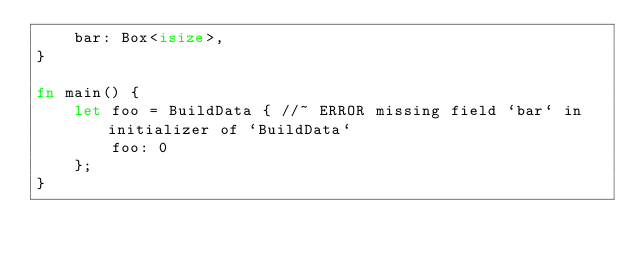Convert code to text. <code><loc_0><loc_0><loc_500><loc_500><_Rust_>    bar: Box<isize>,
}

fn main() {
    let foo = BuildData { //~ ERROR missing field `bar` in initializer of `BuildData`
        foo: 0
    };
}
</code> 